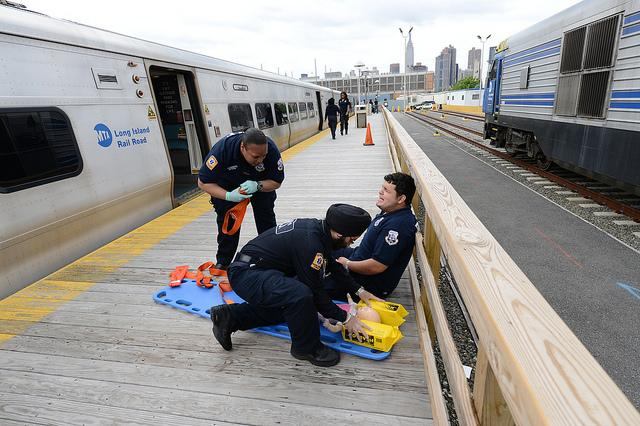Which major US city does this train line service?

Choices:
A) philadelphia
B) new york
C) boston
D) washington d.c new york 